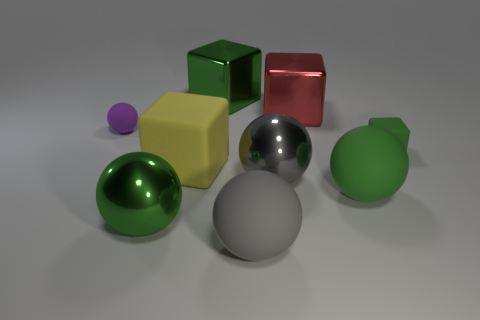Add 1 tiny gray metal balls. How many objects exist? 10 Subtract all green balls. How many balls are left? 3 Subtract all gray balls. How many balls are left? 3 Subtract all balls. How many objects are left? 4 Subtract all gray matte objects. Subtract all big blocks. How many objects are left? 5 Add 4 green metallic blocks. How many green metallic blocks are left? 5 Add 4 small purple spheres. How many small purple spheres exist? 5 Subtract 0 purple cylinders. How many objects are left? 9 Subtract 1 spheres. How many spheres are left? 4 Subtract all gray cubes. Subtract all yellow spheres. How many cubes are left? 4 